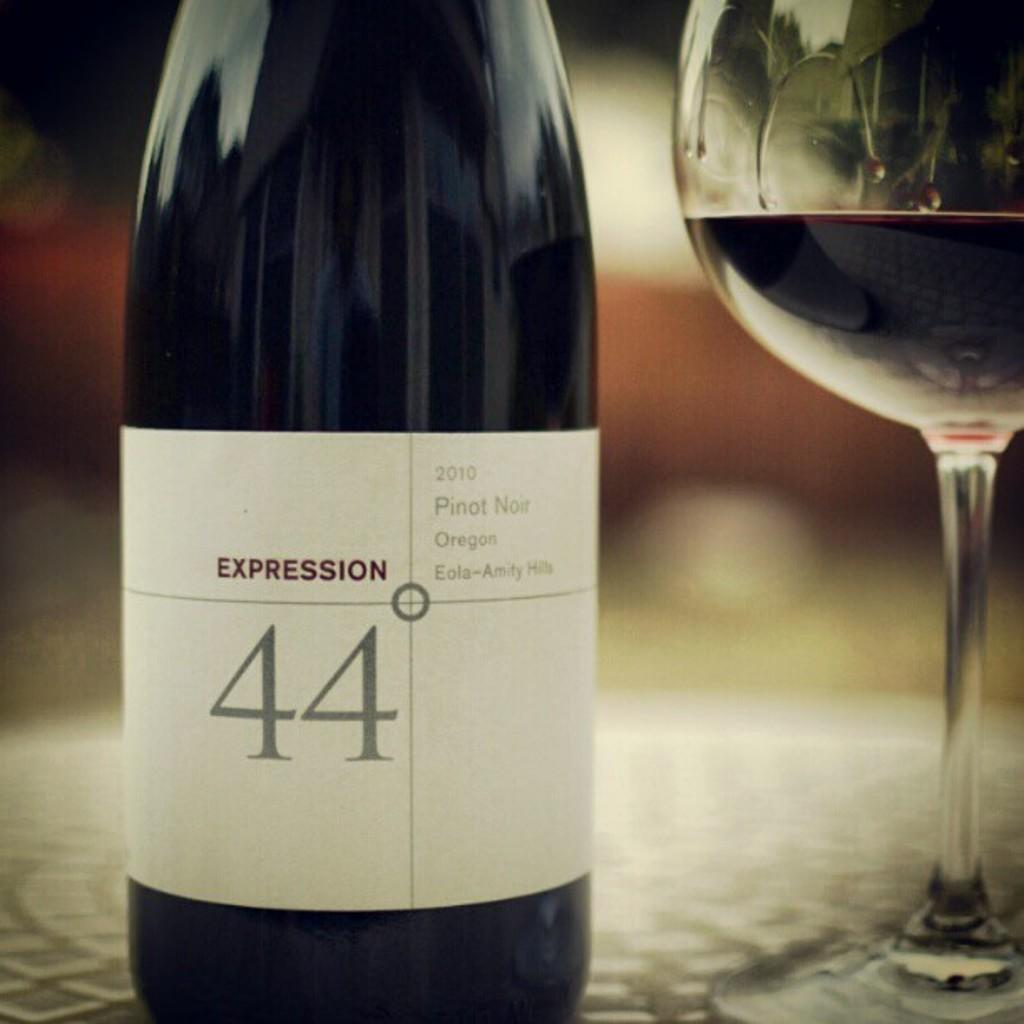<image>
Provide a brief description of the given image. A bottle of Pinot Noir red wine branded with the name Expression 44 degrees. 